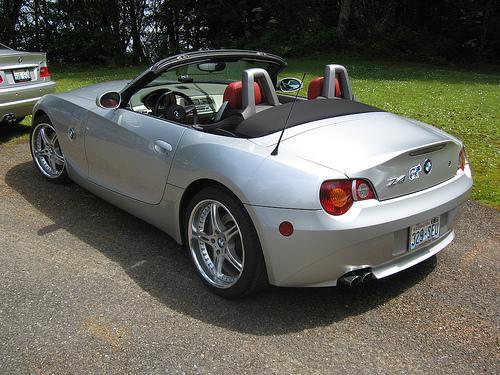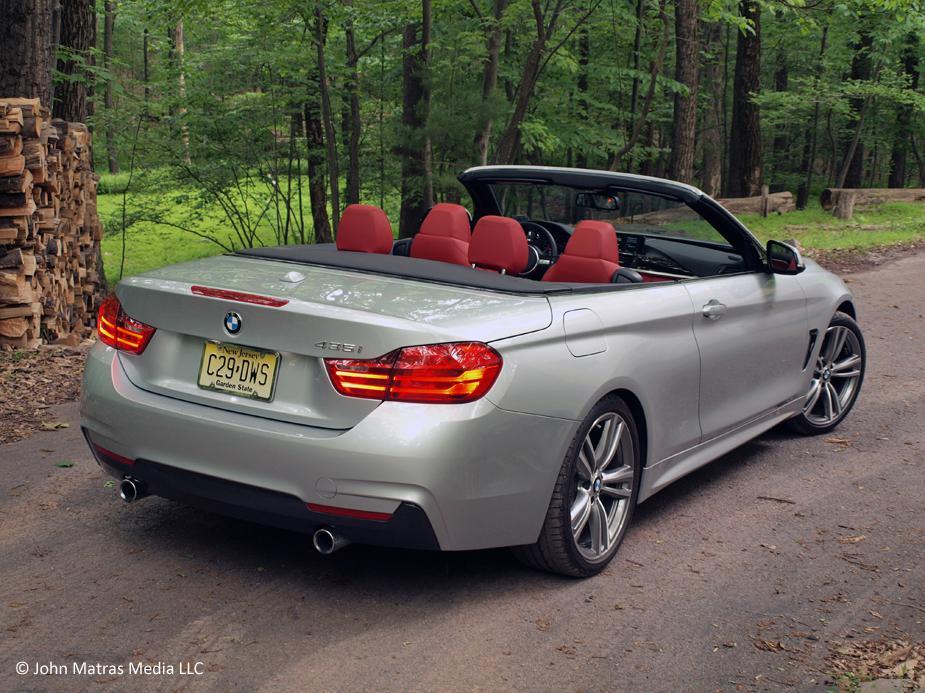The first image is the image on the left, the second image is the image on the right. Evaluate the accuracy of this statement regarding the images: "An image shows a convertible with top down angled rightward, with tailights facing the camera.". Is it true? Answer yes or no. Yes. The first image is the image on the left, the second image is the image on the right. Evaluate the accuracy of this statement regarding the images: "Two sports cars with chrome wheels and dual exhaust are parked at an angle so that the rear license plate is visible.". Is it true? Answer yes or no. Yes. 